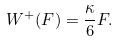Convert formula to latex. <formula><loc_0><loc_0><loc_500><loc_500>W ^ { + } ( F ) = \frac { \kappa } { 6 } F .</formula> 